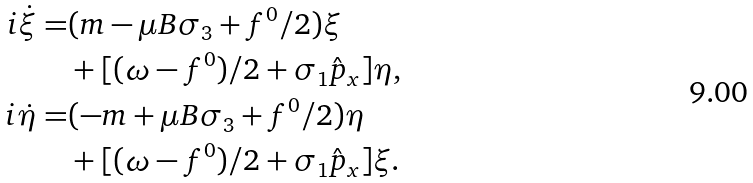Convert formula to latex. <formula><loc_0><loc_0><loc_500><loc_500>i \dot { \xi } = & ( m - \mu B \sigma _ { 3 } + f ^ { 0 } / 2 ) \xi \\ & + [ ( \omega - f ^ { 0 } ) / 2 + \sigma _ { 1 } \hat { p } _ { x } ] \eta , \\ i \dot { \eta } = & ( - m + \mu B \sigma _ { 3 } + f ^ { 0 } / 2 ) \eta \\ & + [ ( \omega - f ^ { 0 } ) / 2 + \sigma _ { 1 } \hat { p } _ { x } ] \xi .</formula> 